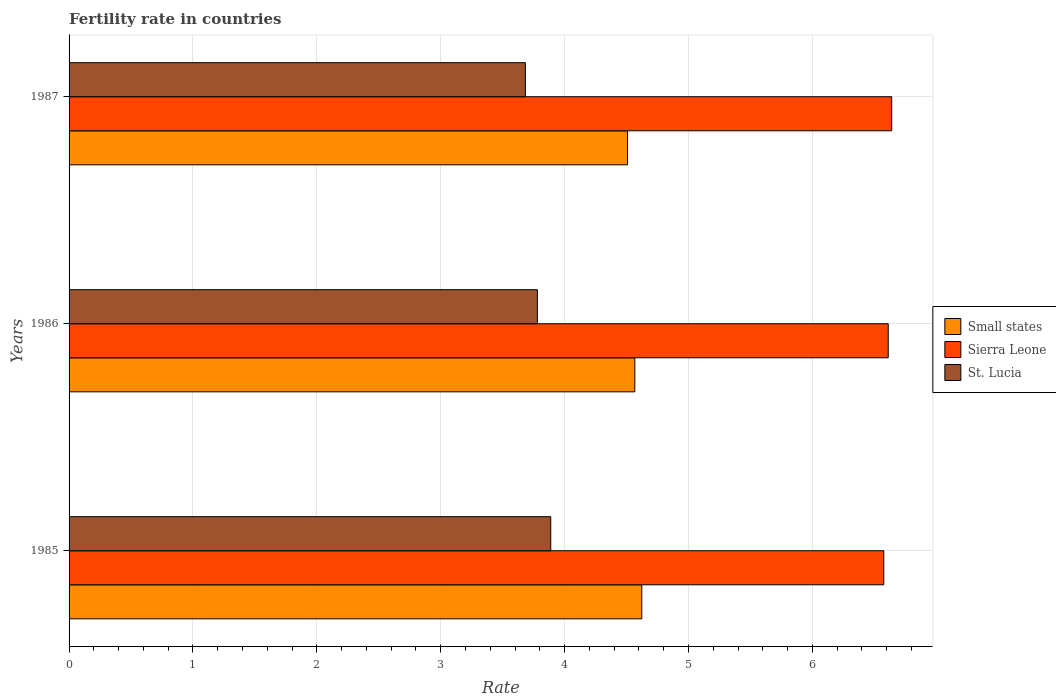How many groups of bars are there?
Give a very brief answer. 3. Are the number of bars per tick equal to the number of legend labels?
Make the answer very short. Yes. Are the number of bars on each tick of the Y-axis equal?
Your answer should be very brief. Yes. What is the fertility rate in St. Lucia in 1986?
Provide a short and direct response. 3.78. Across all years, what is the maximum fertility rate in Small states?
Provide a short and direct response. 4.62. Across all years, what is the minimum fertility rate in Sierra Leone?
Your response must be concise. 6.58. In which year was the fertility rate in St. Lucia maximum?
Give a very brief answer. 1985. In which year was the fertility rate in St. Lucia minimum?
Make the answer very short. 1987. What is the total fertility rate in St. Lucia in the graph?
Your answer should be compact. 11.35. What is the difference between the fertility rate in St. Lucia in 1985 and that in 1986?
Offer a terse response. 0.11. What is the difference between the fertility rate in Small states in 1985 and the fertility rate in St. Lucia in 1986?
Ensure brevity in your answer.  0.84. What is the average fertility rate in Sierra Leone per year?
Your answer should be compact. 6.61. In the year 1985, what is the difference between the fertility rate in St. Lucia and fertility rate in Sierra Leone?
Provide a short and direct response. -2.69. What is the ratio of the fertility rate in Sierra Leone in 1986 to that in 1987?
Offer a terse response. 1. Is the difference between the fertility rate in St. Lucia in 1986 and 1987 greater than the difference between the fertility rate in Sierra Leone in 1986 and 1987?
Ensure brevity in your answer.  Yes. What is the difference between the highest and the second highest fertility rate in Small states?
Your answer should be very brief. 0.06. What is the difference between the highest and the lowest fertility rate in Small states?
Ensure brevity in your answer.  0.12. In how many years, is the fertility rate in St. Lucia greater than the average fertility rate in St. Lucia taken over all years?
Provide a succinct answer. 1. What does the 2nd bar from the top in 1985 represents?
Your answer should be very brief. Sierra Leone. What does the 2nd bar from the bottom in 1985 represents?
Make the answer very short. Sierra Leone. How many years are there in the graph?
Keep it short and to the point. 3. Does the graph contain any zero values?
Your response must be concise. No. How many legend labels are there?
Your response must be concise. 3. What is the title of the graph?
Provide a short and direct response. Fertility rate in countries. What is the label or title of the X-axis?
Offer a terse response. Rate. What is the Rate in Small states in 1985?
Provide a succinct answer. 4.62. What is the Rate of Sierra Leone in 1985?
Your answer should be very brief. 6.58. What is the Rate of St. Lucia in 1985?
Provide a succinct answer. 3.89. What is the Rate in Small states in 1986?
Your answer should be compact. 4.57. What is the Rate in Sierra Leone in 1986?
Give a very brief answer. 6.61. What is the Rate of St. Lucia in 1986?
Your answer should be very brief. 3.78. What is the Rate in Small states in 1987?
Your response must be concise. 4.51. What is the Rate of Sierra Leone in 1987?
Ensure brevity in your answer.  6.64. What is the Rate of St. Lucia in 1987?
Ensure brevity in your answer.  3.68. Across all years, what is the maximum Rate in Small states?
Keep it short and to the point. 4.62. Across all years, what is the maximum Rate in Sierra Leone?
Keep it short and to the point. 6.64. Across all years, what is the maximum Rate in St. Lucia?
Give a very brief answer. 3.89. Across all years, what is the minimum Rate in Small states?
Keep it short and to the point. 4.51. Across all years, what is the minimum Rate in Sierra Leone?
Provide a short and direct response. 6.58. Across all years, what is the minimum Rate in St. Lucia?
Provide a short and direct response. 3.68. What is the total Rate of Small states in the graph?
Provide a succinct answer. 13.7. What is the total Rate of Sierra Leone in the graph?
Make the answer very short. 19.83. What is the total Rate of St. Lucia in the graph?
Your answer should be very brief. 11.35. What is the difference between the Rate of Small states in 1985 and that in 1986?
Offer a very short reply. 0.06. What is the difference between the Rate of Sierra Leone in 1985 and that in 1986?
Keep it short and to the point. -0.04. What is the difference between the Rate in St. Lucia in 1985 and that in 1986?
Offer a terse response. 0.11. What is the difference between the Rate in Small states in 1985 and that in 1987?
Provide a short and direct response. 0.12. What is the difference between the Rate in Sierra Leone in 1985 and that in 1987?
Ensure brevity in your answer.  -0.06. What is the difference between the Rate in St. Lucia in 1985 and that in 1987?
Provide a succinct answer. 0.2. What is the difference between the Rate of Small states in 1986 and that in 1987?
Keep it short and to the point. 0.06. What is the difference between the Rate of Sierra Leone in 1986 and that in 1987?
Your response must be concise. -0.03. What is the difference between the Rate of St. Lucia in 1986 and that in 1987?
Keep it short and to the point. 0.1. What is the difference between the Rate in Small states in 1985 and the Rate in Sierra Leone in 1986?
Offer a very short reply. -1.99. What is the difference between the Rate of Small states in 1985 and the Rate of St. Lucia in 1986?
Ensure brevity in your answer.  0.84. What is the difference between the Rate of Sierra Leone in 1985 and the Rate of St. Lucia in 1986?
Keep it short and to the point. 2.8. What is the difference between the Rate in Small states in 1985 and the Rate in Sierra Leone in 1987?
Provide a short and direct response. -2.02. What is the difference between the Rate in Small states in 1985 and the Rate in St. Lucia in 1987?
Your answer should be compact. 0.94. What is the difference between the Rate in Sierra Leone in 1985 and the Rate in St. Lucia in 1987?
Your answer should be very brief. 2.89. What is the difference between the Rate of Small states in 1986 and the Rate of Sierra Leone in 1987?
Your answer should be compact. -2.07. What is the difference between the Rate in Small states in 1986 and the Rate in St. Lucia in 1987?
Ensure brevity in your answer.  0.88. What is the difference between the Rate in Sierra Leone in 1986 and the Rate in St. Lucia in 1987?
Make the answer very short. 2.93. What is the average Rate in Small states per year?
Your answer should be compact. 4.57. What is the average Rate of Sierra Leone per year?
Offer a very short reply. 6.61. What is the average Rate of St. Lucia per year?
Your answer should be compact. 3.78. In the year 1985, what is the difference between the Rate in Small states and Rate in Sierra Leone?
Make the answer very short. -1.95. In the year 1985, what is the difference between the Rate of Small states and Rate of St. Lucia?
Offer a very short reply. 0.73. In the year 1985, what is the difference between the Rate of Sierra Leone and Rate of St. Lucia?
Offer a terse response. 2.69. In the year 1986, what is the difference between the Rate of Small states and Rate of Sierra Leone?
Ensure brevity in your answer.  -2.05. In the year 1986, what is the difference between the Rate of Small states and Rate of St. Lucia?
Ensure brevity in your answer.  0.79. In the year 1986, what is the difference between the Rate in Sierra Leone and Rate in St. Lucia?
Your response must be concise. 2.83. In the year 1987, what is the difference between the Rate of Small states and Rate of Sierra Leone?
Your answer should be very brief. -2.13. In the year 1987, what is the difference between the Rate of Small states and Rate of St. Lucia?
Offer a very short reply. 0.82. In the year 1987, what is the difference between the Rate of Sierra Leone and Rate of St. Lucia?
Offer a very short reply. 2.96. What is the ratio of the Rate in Small states in 1985 to that in 1986?
Give a very brief answer. 1.01. What is the ratio of the Rate in Sierra Leone in 1985 to that in 1986?
Keep it short and to the point. 0.99. What is the ratio of the Rate in St. Lucia in 1985 to that in 1986?
Ensure brevity in your answer.  1.03. What is the ratio of the Rate in Small states in 1985 to that in 1987?
Keep it short and to the point. 1.03. What is the ratio of the Rate of St. Lucia in 1985 to that in 1987?
Provide a succinct answer. 1.06. What is the ratio of the Rate in Small states in 1986 to that in 1987?
Make the answer very short. 1.01. What is the ratio of the Rate of Sierra Leone in 1986 to that in 1987?
Keep it short and to the point. 1. What is the ratio of the Rate of St. Lucia in 1986 to that in 1987?
Your answer should be very brief. 1.03. What is the difference between the highest and the second highest Rate in Small states?
Give a very brief answer. 0.06. What is the difference between the highest and the second highest Rate of Sierra Leone?
Make the answer very short. 0.03. What is the difference between the highest and the second highest Rate in St. Lucia?
Offer a very short reply. 0.11. What is the difference between the highest and the lowest Rate of Small states?
Provide a succinct answer. 0.12. What is the difference between the highest and the lowest Rate in Sierra Leone?
Your response must be concise. 0.06. What is the difference between the highest and the lowest Rate of St. Lucia?
Provide a succinct answer. 0.2. 